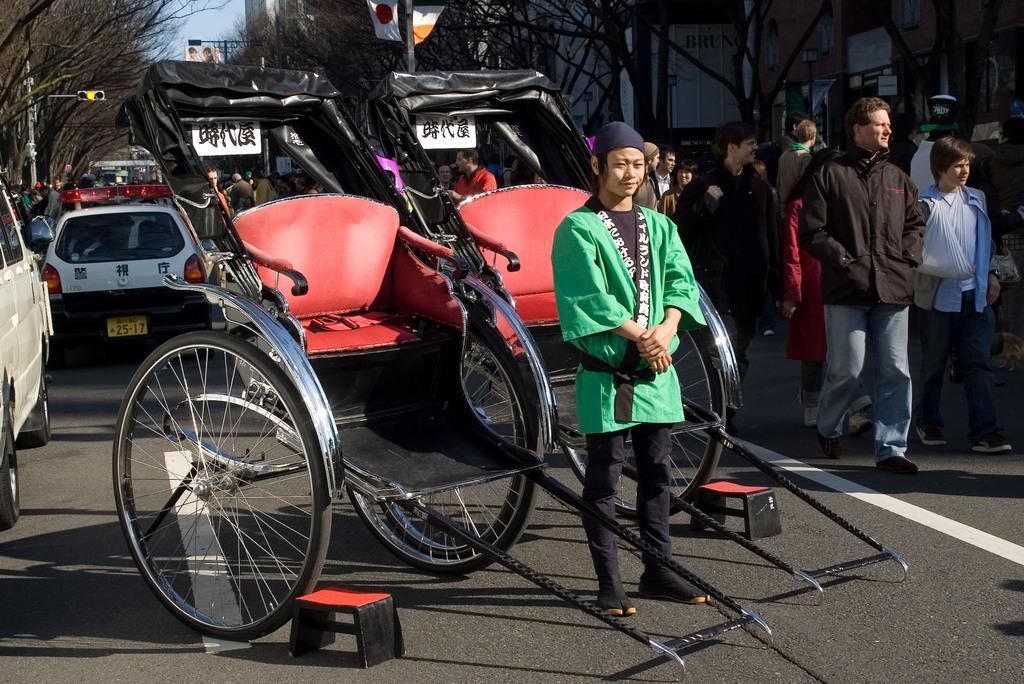How would you summarize this image in a sentence or two? In the center of the image we can see the cart vehicle. We can also see the stools on the road. There is also a person standing. In the background we can see the vehicles, poles, people and also the buildings. We can also see the flags. Sky is also visible. 